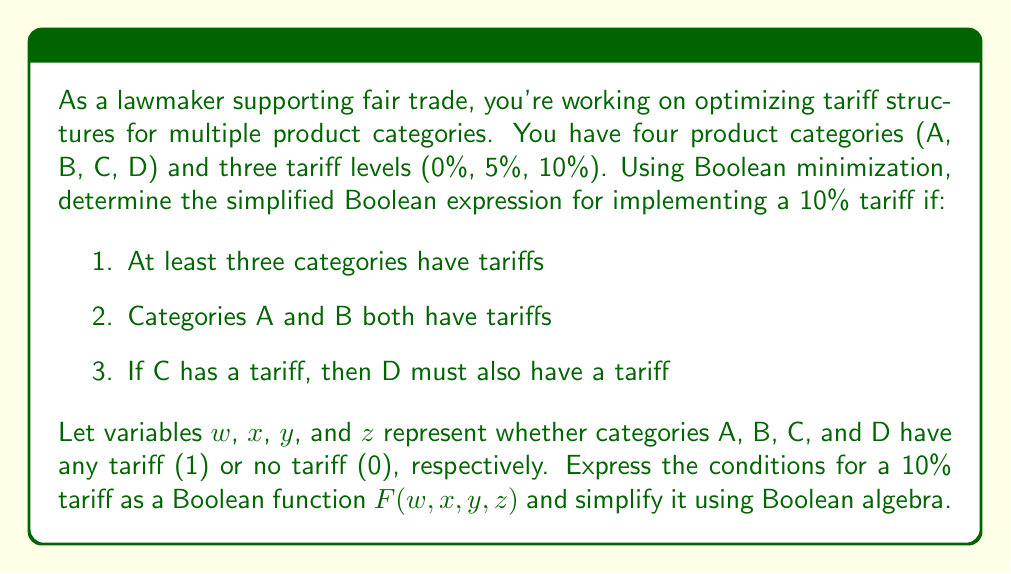Give your solution to this math problem. Let's approach this step-by-step:

1) First, let's express each condition as a Boolean expression:
   - At least three categories have tariffs: $wx + wy + wz + xy + xz + yz$
   - Categories A and B both have tariffs: $wx$
   - If C has a tariff, then D must also have a tariff: $y'+ z$ (equivalent to $y \implies z$)

2) Combine these conditions using AND operation:
   $F(w,x,y,z) = (wx + wy + wz + xy + xz + yz) \cdot wx \cdot (y' + z)$

3) Distribute $wx$ over the first parenthesis:
   $F(w,x,y,z) = (wx + wxy + wxz + wx + wxz + wxyz) \cdot (y' + z)$

4) Simplify using idempotent law ($wx + wx = wx$) and absorption law ($wx + wxy = wx$):
   $F(w,x,y,z) = wx \cdot (y' + z)$

5) Distribute $(y' + z)$:
   $F(w,x,y,z) = wxy' + wxz$

This is the simplified Boolean expression for implementing a 10% tariff based on the given conditions.
Answer: $wxy' + wxz$ 